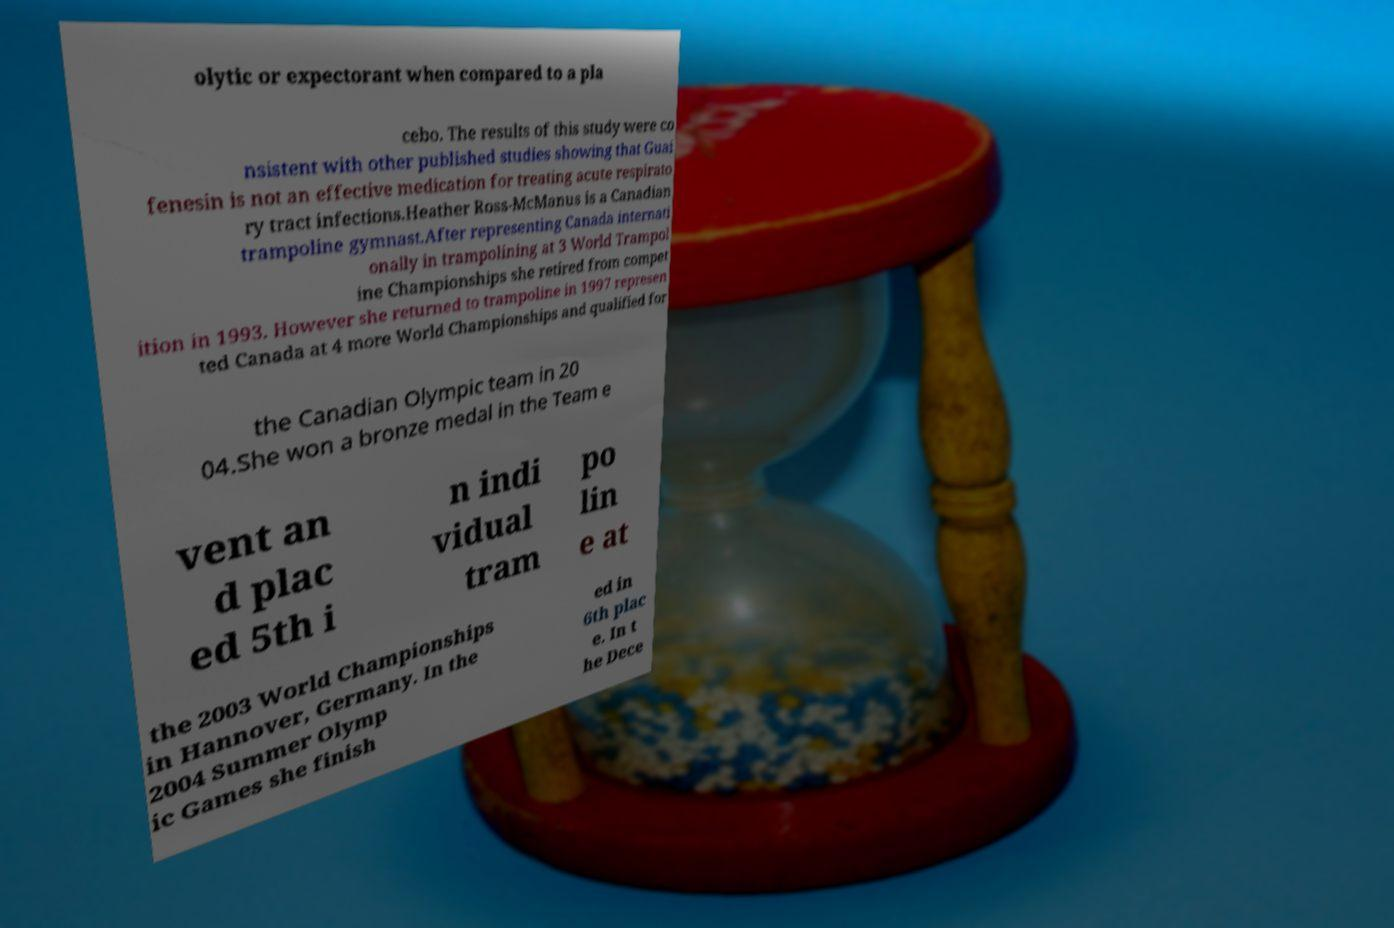I need the written content from this picture converted into text. Can you do that? olytic or expectorant when compared to a pla cebo. The results of this study were co nsistent with other published studies showing that Guai fenesin is not an effective medication for treating acute respirato ry tract infections.Heather Ross-McManus is a Canadian trampoline gymnast.After representing Canada internati onally in trampolining at 3 World Trampol ine Championships she retired from compet ition in 1993. However she returned to trampoline in 1997 represen ted Canada at 4 more World Championships and qualified for the Canadian Olympic team in 20 04.She won a bronze medal in the Team e vent an d plac ed 5th i n indi vidual tram po lin e at the 2003 World Championships in Hannover, Germany. In the 2004 Summer Olymp ic Games she finish ed in 6th plac e. In t he Dece 